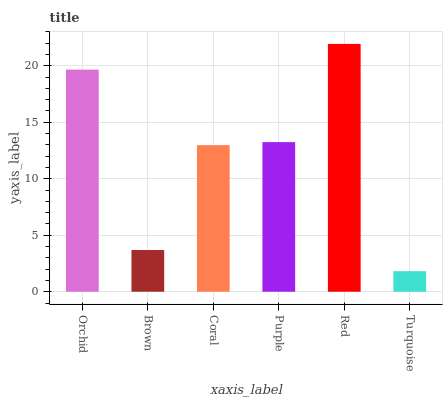Is Brown the minimum?
Answer yes or no. No. Is Brown the maximum?
Answer yes or no. No. Is Orchid greater than Brown?
Answer yes or no. Yes. Is Brown less than Orchid?
Answer yes or no. Yes. Is Brown greater than Orchid?
Answer yes or no. No. Is Orchid less than Brown?
Answer yes or no. No. Is Purple the high median?
Answer yes or no. Yes. Is Coral the low median?
Answer yes or no. Yes. Is Red the high median?
Answer yes or no. No. Is Red the low median?
Answer yes or no. No. 